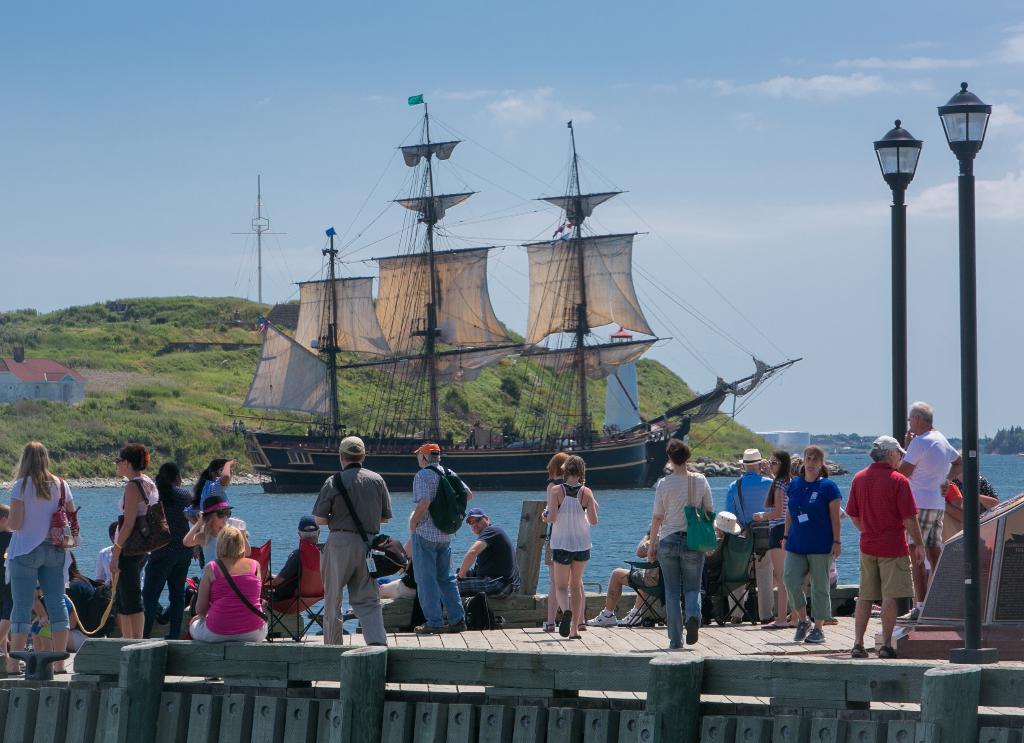Can you describe this image briefly? Here in this picture we can see number of people standing and walking on a place over there and we can also see some people sitting on chairs over there and we can see some people are wearing caps and hats and carrying handbags and bags with them and on the right side we can see lamp posts present over there and in front of them we can see water present all over there and we can also see a ship present in that over there and we can also see mountains that is fully covered with grass and plants over there and we can see cloud sin the sky over there. 